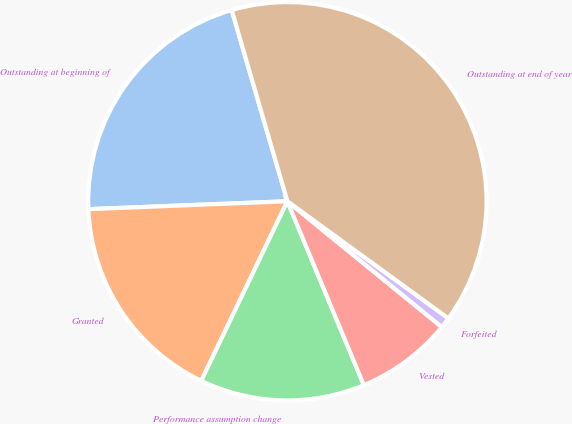Convert chart to OTSL. <chart><loc_0><loc_0><loc_500><loc_500><pie_chart><fcel>Outstanding at beginning of<fcel>Granted<fcel>Performance assumption change<fcel>Vested<fcel>Forfeited<fcel>Outstanding at end of year<nl><fcel>21.12%<fcel>17.25%<fcel>13.39%<fcel>7.85%<fcel>0.87%<fcel>39.52%<nl></chart> 